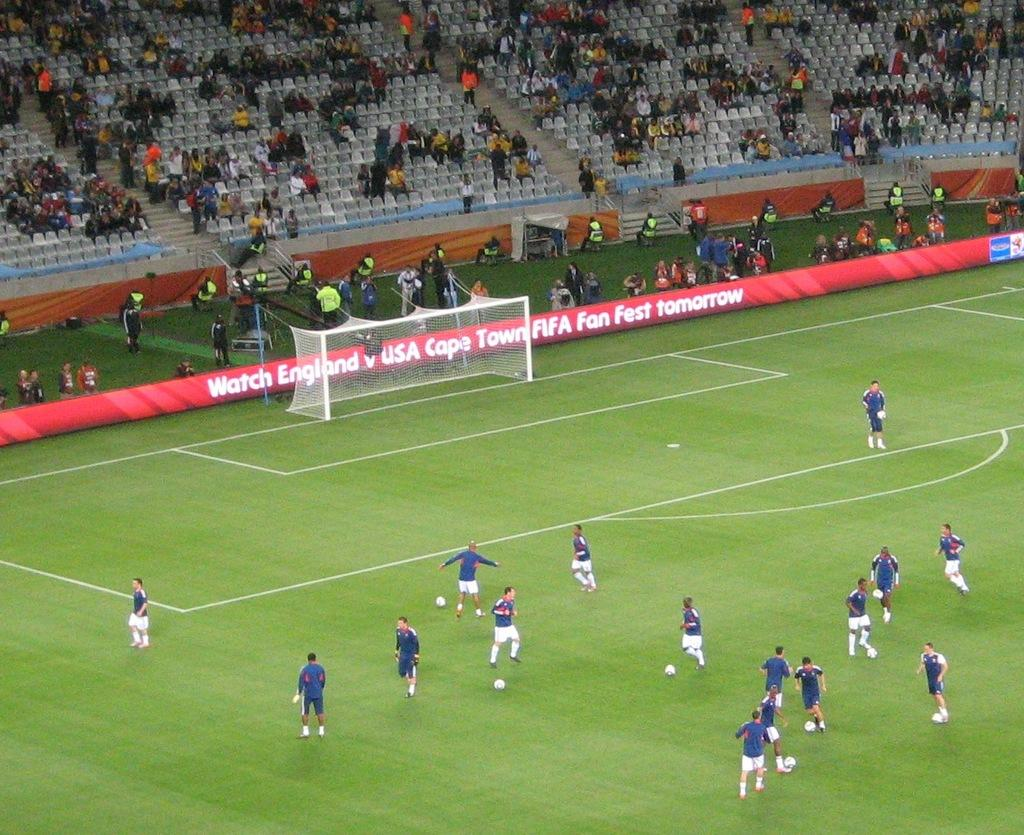<image>
Offer a succinct explanation of the picture presented. Soccer players practice on a field that is advertising tomorrow's game. 